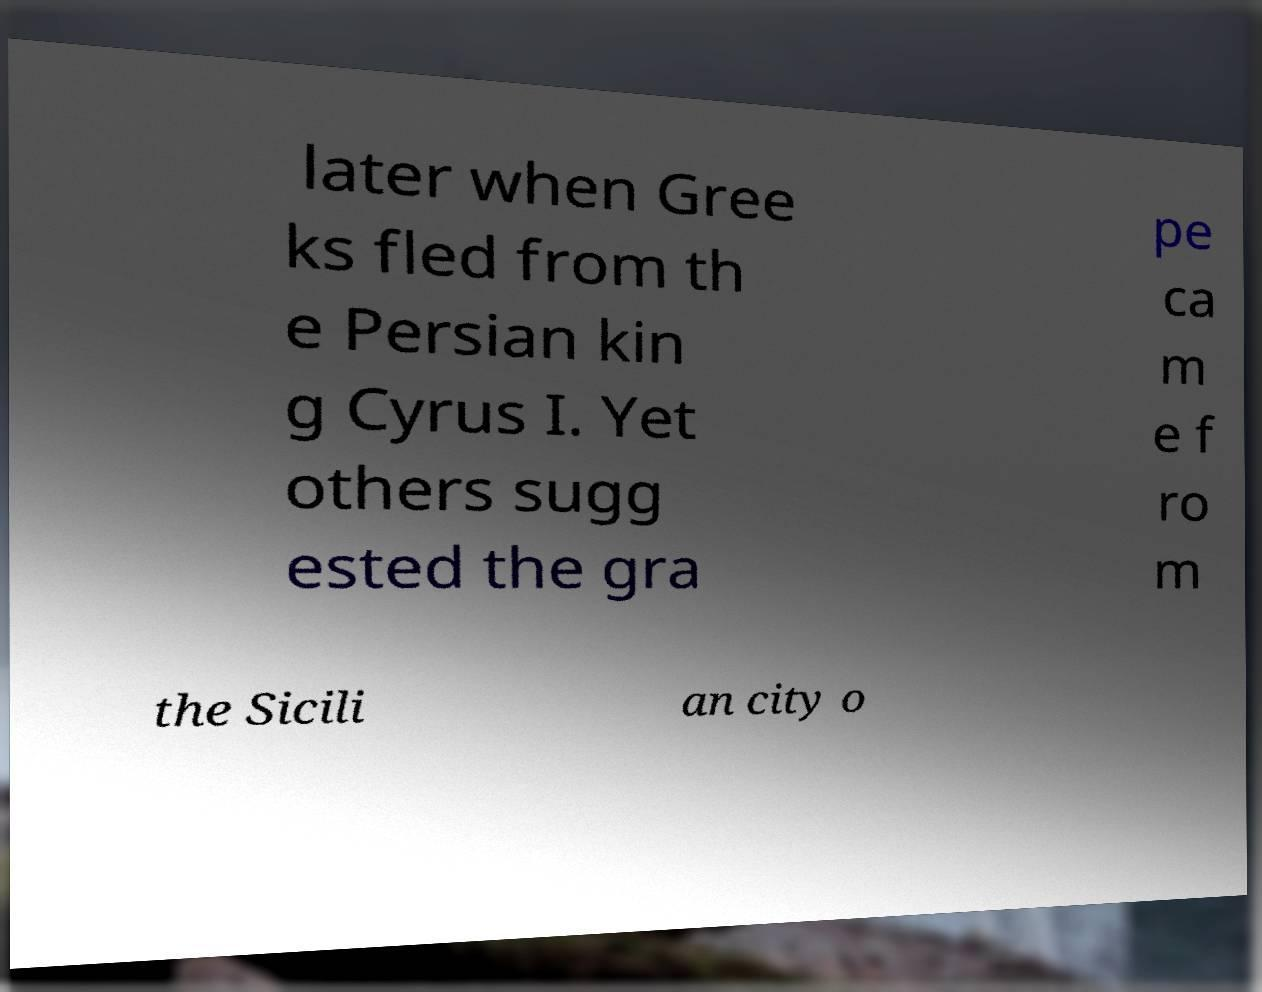Could you extract and type out the text from this image? later when Gree ks fled from th e Persian kin g Cyrus I. Yet others sugg ested the gra pe ca m e f ro m the Sicili an city o 